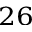Convert formula to latex. <formula><loc_0><loc_0><loc_500><loc_500>^ { 2 6 }</formula> 